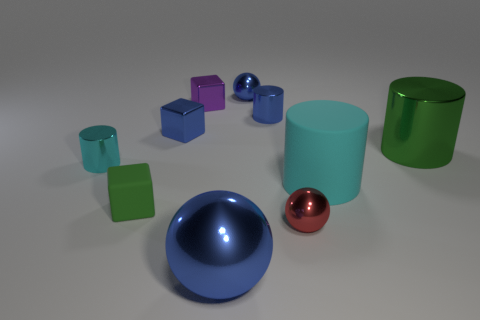How might the shadows in this scene inform us about the light source? The shadows in this scene are soft and diffuse, indicating the light source is not extremely close to the objects. The direction of the shadows suggests the light is coming from the right-hand side of the frame, somewhat elevated, casting consistent shadows to the left and slightly downward across all objects. 